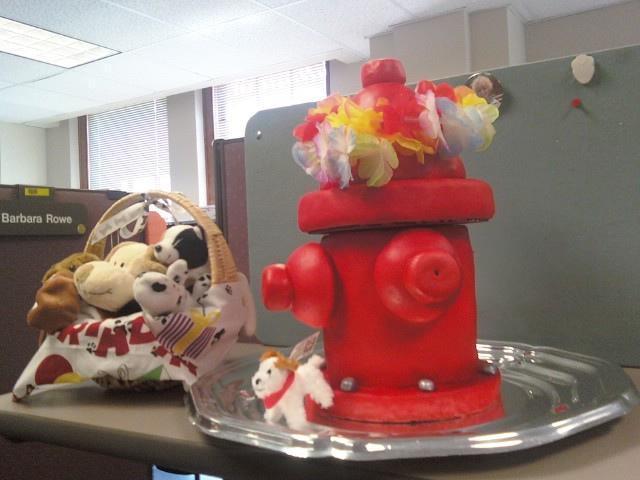Does the caption "The teddy bear is against the fire hydrant." correctly depict the image?
Answer yes or no. No. Verify the accuracy of this image caption: "The fire hydrant is beside the teddy bear.".
Answer yes or no. Yes. 